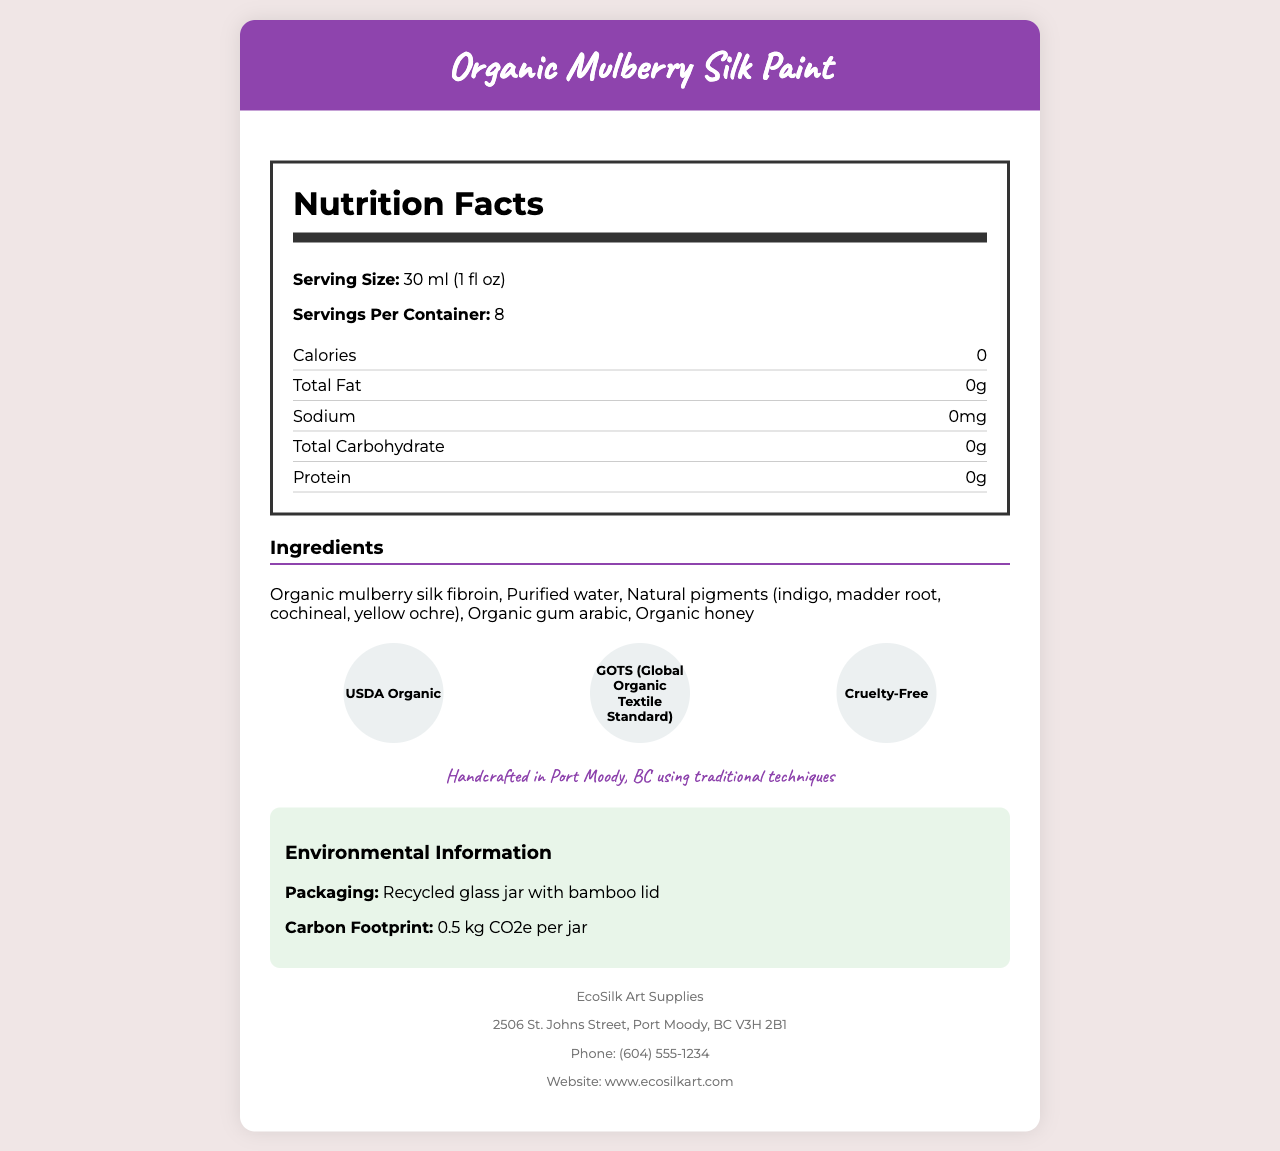what is the serving size of the Organic Mulberry Silk Paint? The serving size is mentioned as "30 ml (1 fl oz)" under the Nutrition Facts section.
Answer: 30 ml (1 fl oz) how many calories are in one serving of the Organic Mulberry Silk Paint? The calorie content per serving is listed as 0 in the Nutrition Facts section.
Answer: 0 what are the main ingredients in the Organic Mulberry Silk Paint? These ingredients are listed under the Ingredients section of the document.
Answer: Organic mulberry silk fibroin, Purified water, Natural pigments (indigo, madder root, cochineal, yellow ochre), Organic gum arabic, Organic honey how many servings are there per container of the Organic Mulberry Silk Paint? The document specifies "Servings Per Container: 8" under the Nutrition Facts section.
Answer: 8 is there any iron in the Organic Mulberry Silk Paint? The Nutrition Facts state that the iron content is 0%.
Answer: 0% what is the packaging material for the Organic Mulberry Silk Paint? This information is found under the Environmental Information section, specifically under Packaging.
Answer: Recycled glass jar with bamboo lid what is the carbon footprint of the Organic Mulberry Silk Paint per jar? The carbon footprint is stated as "0.5 kg CO2e per jar" in the Environmental Information section.
Answer: 0.5 kg CO2e per jar what is the origin of the yellow ochre pigment in the Organic Mulberry Silk Paint? A. Indigofera tinctoria plant B. Rubia tinctorum plant C. Dactylopius coccus insect D. Natural earth pigment The origin of yellow ochre is stated as "Natural earth pigment" in the Pigment Origin section.
Answer: D how many certifications does the Organic Mulberry Silk Paint have? A. One B. Two C. Three D. Four The document lists three certifications: USDA Organic, GOTS (Global Organic Textile Standard), and Cruelty-Free.
Answer: C was the Organic Mulberry Silk Paint tested on animals? The Cruelty-Free certification indicates that the product was not tested on animals.
Answer: No can people with silk protein allergies use this paint? The document specifies that the paint contains silk proteins and may cause allergic reactions in sensitive individuals.
Answer: No describe the entire document or the main idea of the document The document is an in-depth overview of the Organic Mulberry Silk Paint, aimed at informing consumers about its nutritional facts, ingredients, origins, and certifications, while also providing environmental and allergen information.
Answer: The Organic Mulberry Silk Paint document provides comprehensive information about the product, including its serving size, calorie content, ingredients, and nutritional facts. It highlights that the paint is handcrafted in Port Moody, BC, using traditional techniques. The document details the packaging, carbon footprint, usage, certifications, pigment origins, and manufacturer information. It emphasizes that the paint is USDA Organic, GOTS certified, and cruelty-free, and also mentions potential allergens and environmental aspects. what is the address of the manufacturer? This address is found in the Manufacturer Info section at the end of the document.
Answer: 2506 St. Johns Street, Port Moody, BC V3H 2B1 what is the viscosity of the Organic Mulberry Silk Paint? The viscosity is listed as "Medium" in the document.
Answer: Medium how should the Organic Mulberry Silk Paint be stored? The shelf life section mentions that the paint should be stored in a cool, dry place for optimal longevity.
Answer: In a cool, dry place was this paint handcrafted in Vancouver? The document states that the paint was handcrafted in Port Moody, BC, specifically.
Answer: No what is the lightfastness rating of the Organic Mulberry Silk Paint? This information is found under Lightfastness in the document.
Answer: Excellent (8 on the Blue Wool Scale) how many milligrams of sodium are in each serving? The sodium content is listed as "0mg" in the Nutrition Facts section.
Answer: 0mg what is the phone number of the manufacturer? The phone number is listed in the Manufacturer Info section of the document.
Answer: (604) 555-1234 is the Organic Mulberry Silk Paint suitable for use in mixed media art? The usage section states that it is suitable for silk painting, watercolor, and mixed media art.
Answer: Yes which plant is the madder root pigment derived from? The madder root pigment is derived from the Rubia tinctorum plant, as stated in the Pigment Origin section.
Answer: Rubia tinctorum how much protein is there per serving in the Organic Mulberry Silk Paint? The protein content per serving is stated as 0g in the Nutrition Facts section.
Answer: 0g who is the manufacturer of the Organic Mulberry Silk Paint? This information is found in the Manufacturer Info section.
Answer: EcoSilk Art Supplies where was the mulberry silk fibroin sourced from? The document lists the ingredients and pigments' origins, but it does not specify the source of the mulberry silk fibroin.
Answer: Cannot be determined 